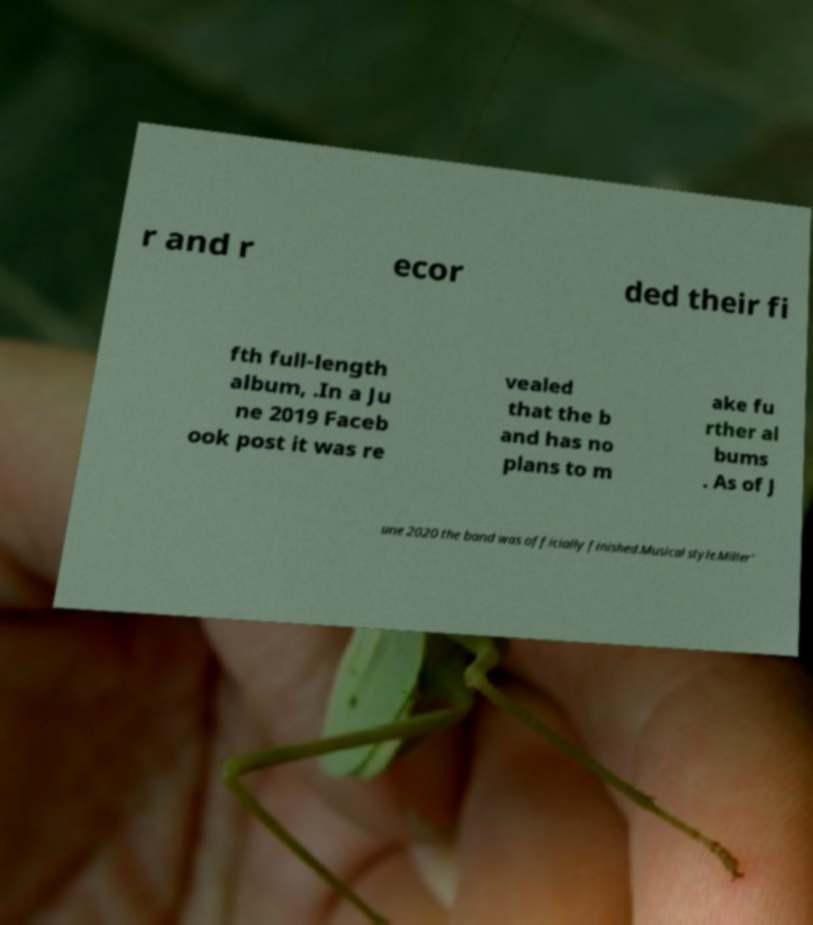I need the written content from this picture converted into text. Can you do that? r and r ecor ded their fi fth full-length album, .In a Ju ne 2019 Faceb ook post it was re vealed that the b and has no plans to m ake fu rther al bums . As of J une 2020 the band was officially finished.Musical style.Miller' 